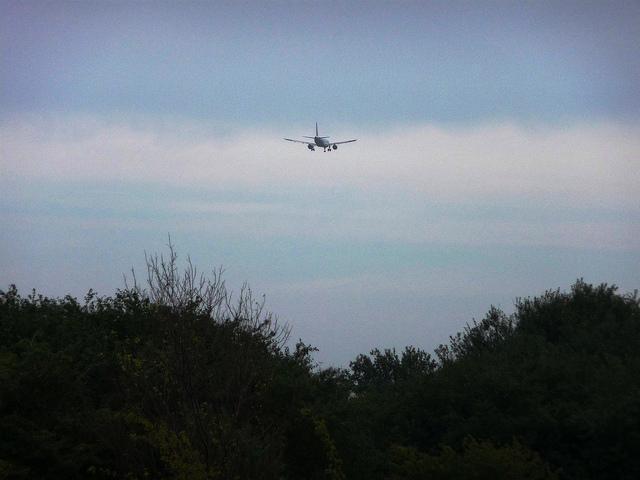How many planes are flying in formation?
Give a very brief answer. 1. 